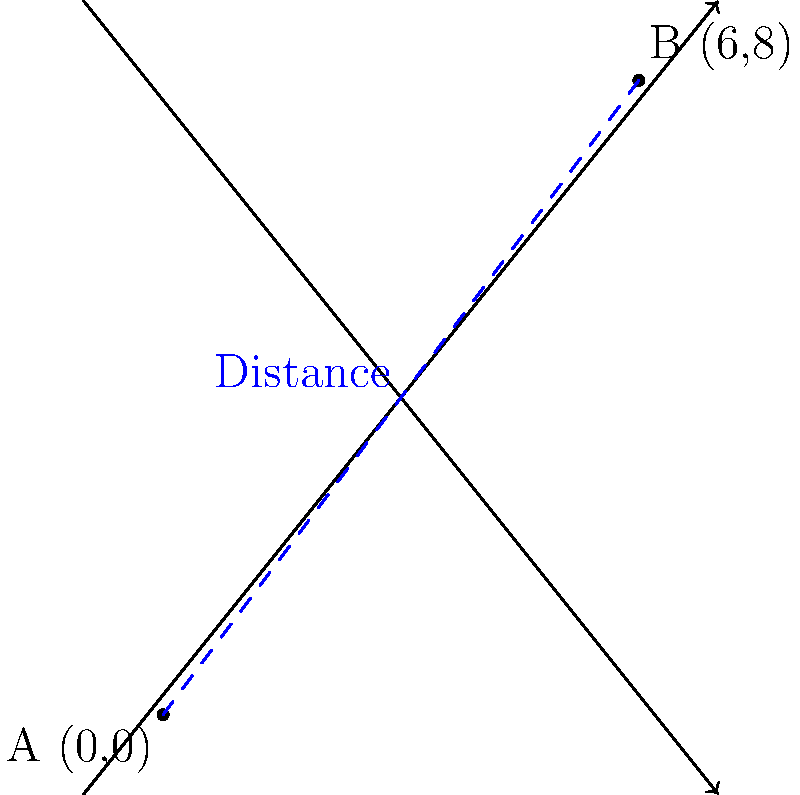In your mystery novel, your detective needs to travel from point A (0,0) to point B (6,8) on a city map. Each unit on the map represents 1 kilometer. Calculate the straight-line distance the detective needs to travel between these two points. Round your answer to the nearest tenth of a kilometer. To find the distance between two points on a coordinate plane, we can use the distance formula:

$$ d = \sqrt{(x_2 - x_1)^2 + (y_2 - y_1)^2} $$

Where $(x_1, y_1)$ is the first point and $(x_2, y_2)$ is the second point.

Given:
Point A: $(0, 0)$
Point B: $(6, 8)$

Step 1: Plug the values into the distance formula:
$$ d = \sqrt{(6 - 0)^2 + (8 - 0)^2} $$

Step 2: Simplify inside the parentheses:
$$ d = \sqrt{6^2 + 8^2} $$

Step 3: Calculate the squares:
$$ d = \sqrt{36 + 64} $$

Step 4: Add under the square root:
$$ d = \sqrt{100} $$

Step 5: Simplify the square root:
$$ d = 10 $$

The exact distance is 10 kilometers. Since the question asks to round to the nearest tenth, the final answer remains 10.0 kilometers.
Answer: 10.0 km 